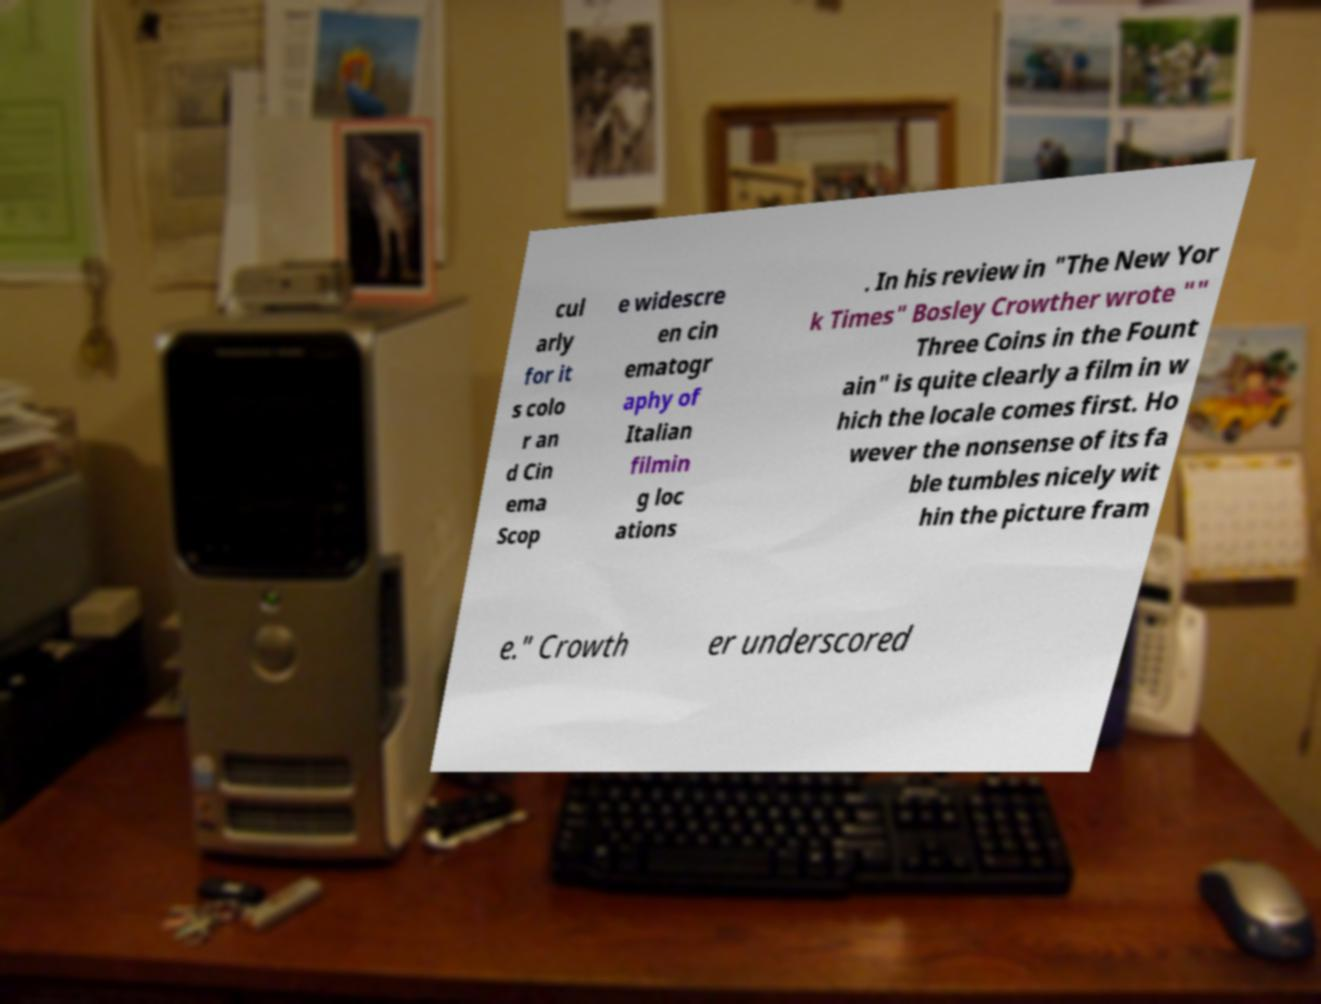Can you accurately transcribe the text from the provided image for me? cul arly for it s colo r an d Cin ema Scop e widescre en cin ematogr aphy of Italian filmin g loc ations . In his review in "The New Yor k Times" Bosley Crowther wrote "" Three Coins in the Fount ain" is quite clearly a film in w hich the locale comes first. Ho wever the nonsense of its fa ble tumbles nicely wit hin the picture fram e." Crowth er underscored 